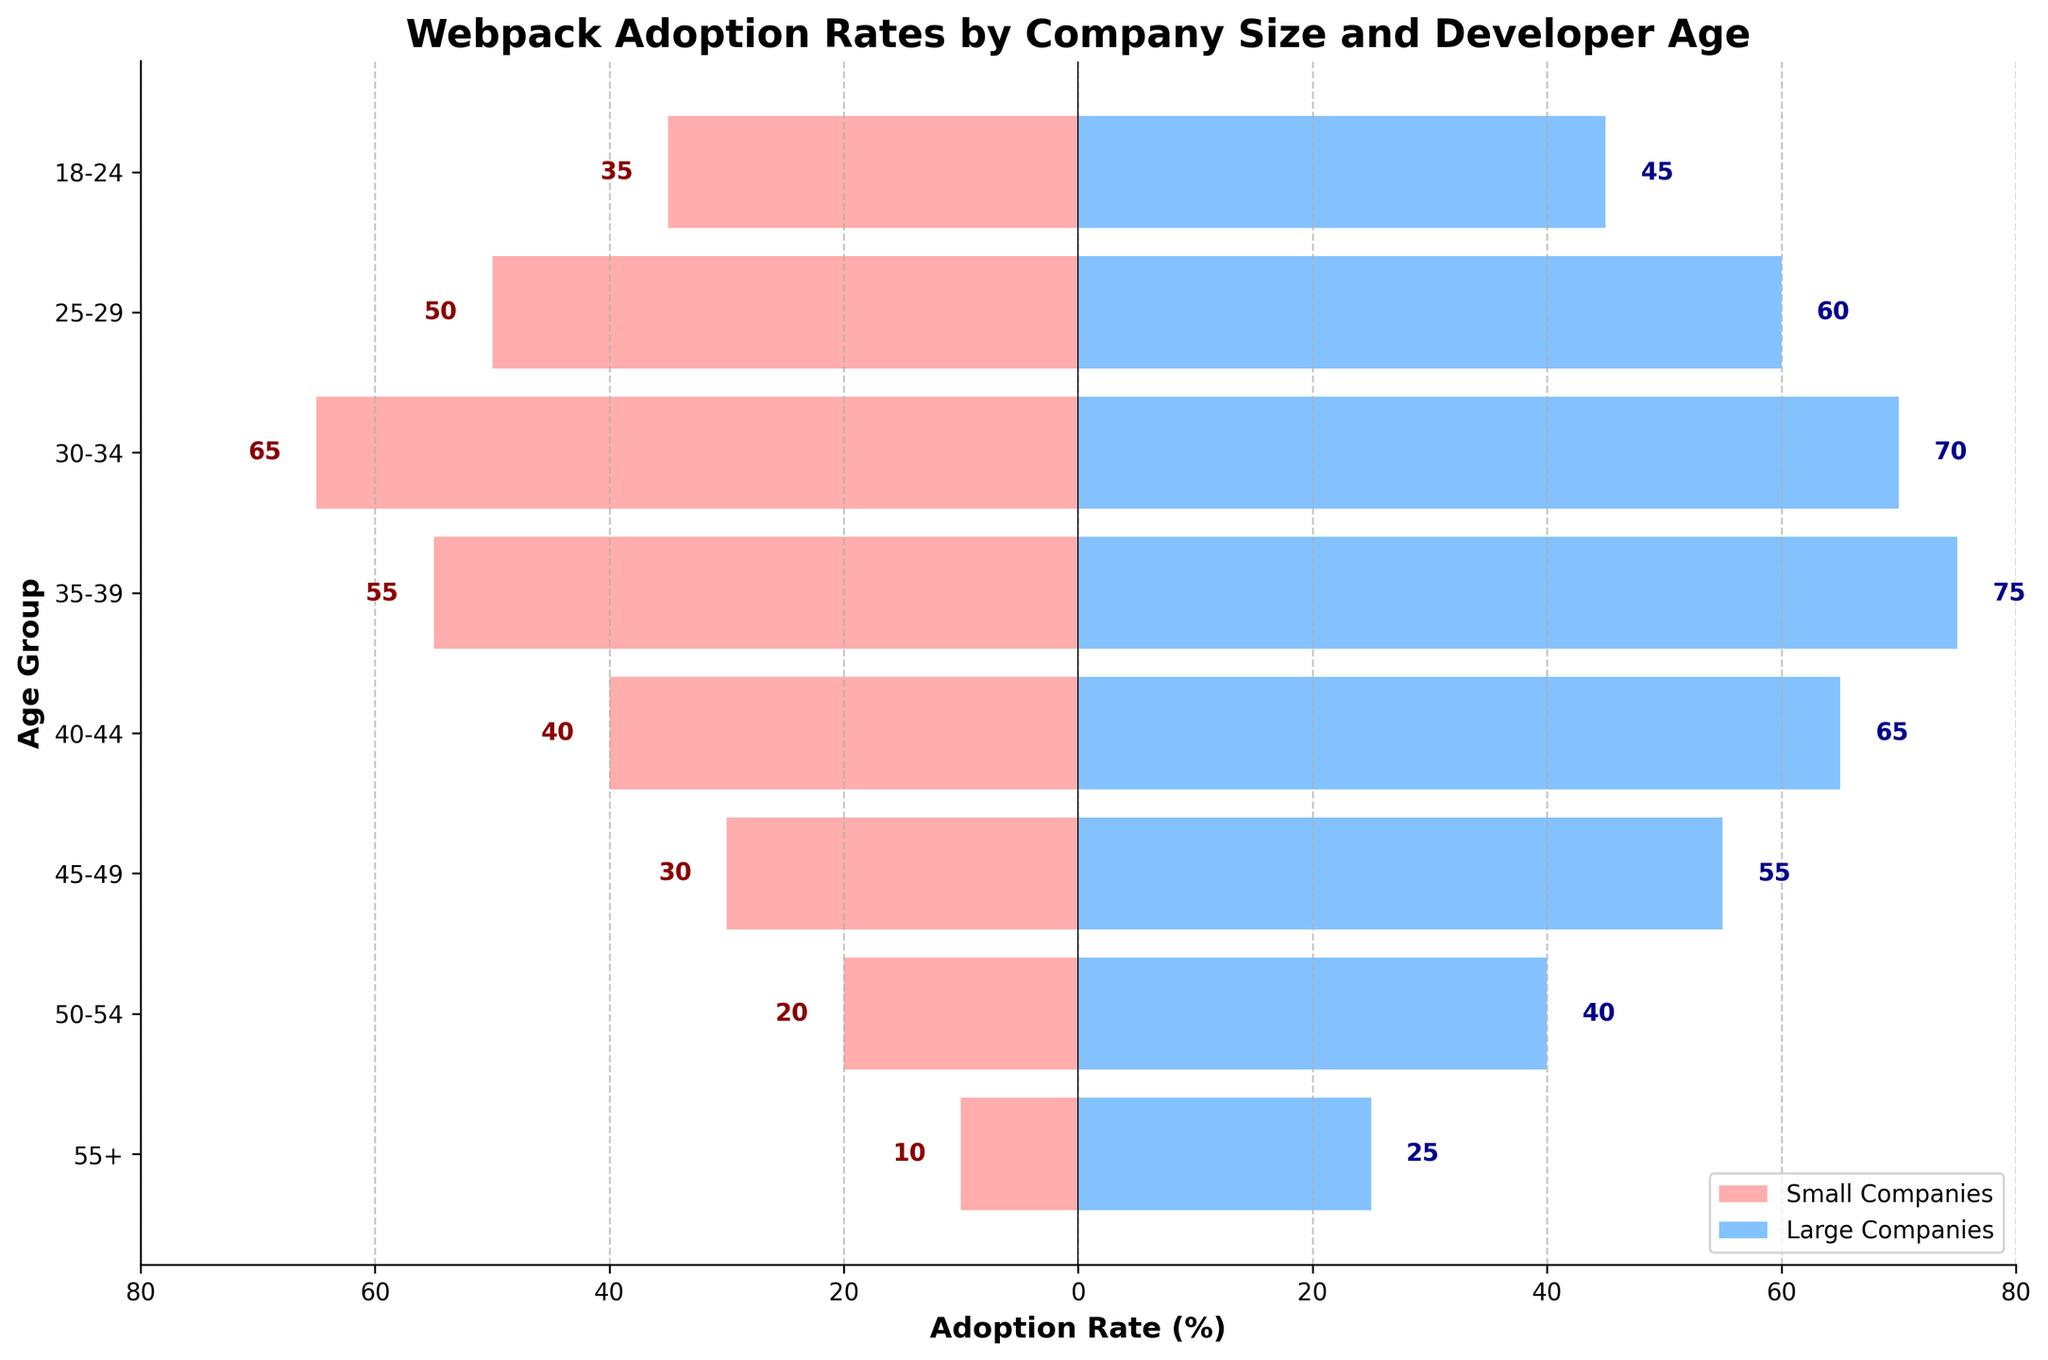What's the title of the figure? The title of the figure is displayed prominently at the top. It reads "Webpack Adoption Rates by Company Size and Developer Age".
Answer: Webpack Adoption Rates by Company Size and Developer Age How many age groups are displayed in the figure? The figure uses a horizontal bar chart to display data, and on the y-axis, there are labels for each age group. Counting these labels gives the total number of age groups.
Answer: 8 Which age group has the highest adoption rate in large companies? By looking at the length of the blue bars representing large companies, the one extending the furthest corresponds to the age group 35-39.
Answer: 35-39 What is the difference in adoption rates between small and large companies for the age group 25-29? The adoption rate for small companies (age group 25-29) is 50, and for large companies, it's 60. The difference is 60 - 50.
Answer: 10 In which age group is the adoption rate by small companies equal to 65? The bars for small companies are red, and by matching the value 65 to the corresponding red bar, it's clear that this occurs in the age group 30-34.
Answer: 30-34 What's the combined adoption rate for small companies for all age groups? Summing the adoption rates for small companies across all age groups gives 35 + 50 + 65 + 55 + 40 + 30 + 20 + 10.
Answer: 305 How does the adoption rate for the age group 50-54 in large companies compare to small companies? The bar for large companies at age group 50-54 is longer than the one for small companies, indicating a higher adoption rate. Specifically, it's 40 for large companies and 20 for small companies.
Answer: Higher Which age group has more evenly distributed adoption rates between small and large companies? This is determined by looking at bars of similar lengths for both company sizes. The age group 18-24 has bars that are relatively close in length (35 for small, 45 for large).
Answer: 18-24 